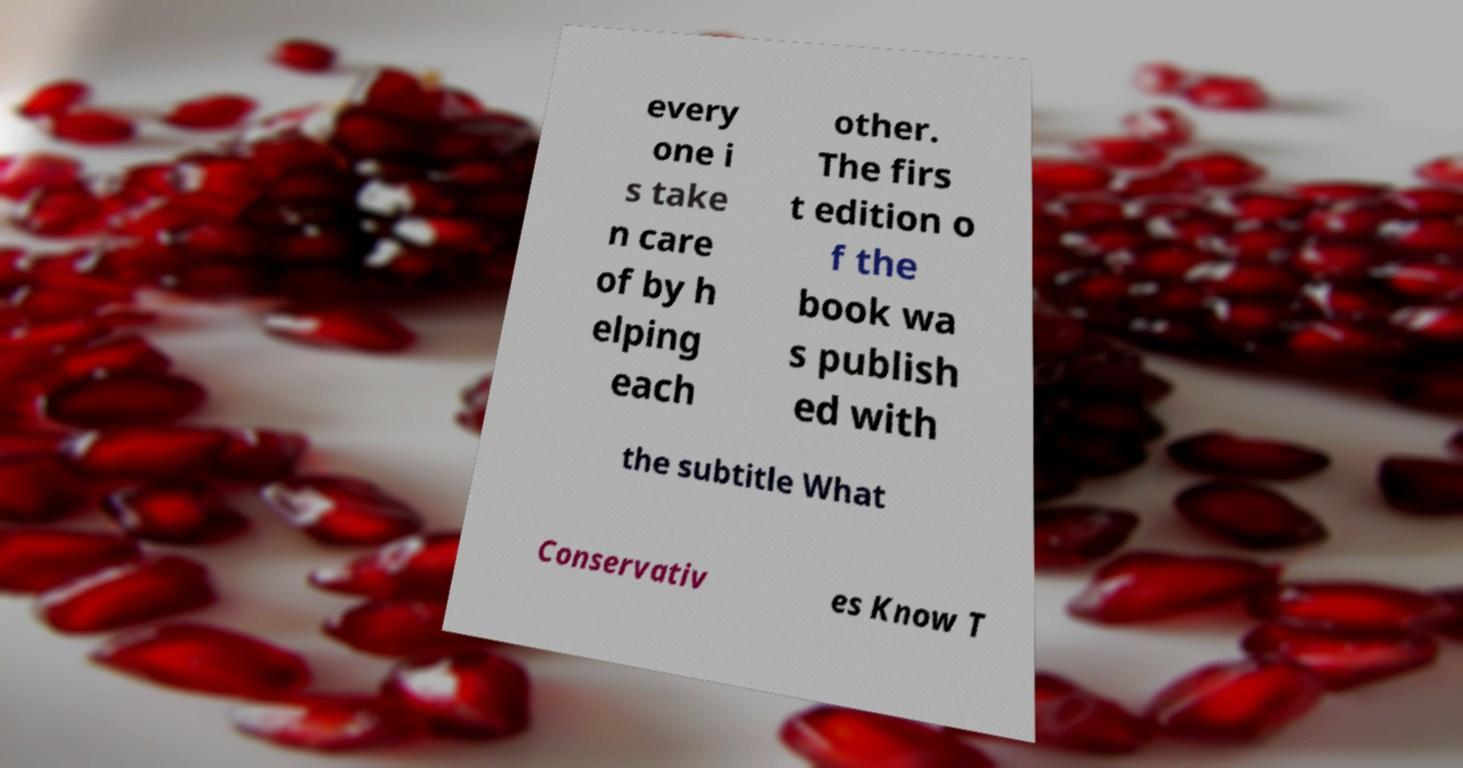I need the written content from this picture converted into text. Can you do that? every one i s take n care of by h elping each other. The firs t edition o f the book wa s publish ed with the subtitle What Conservativ es Know T 